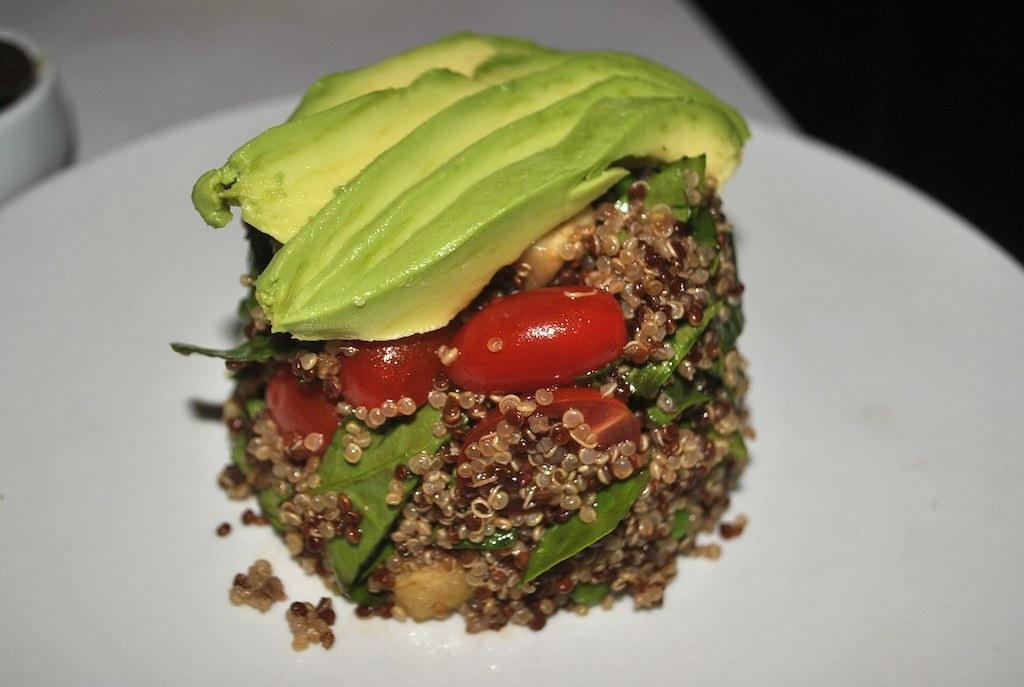What is on the plate that is visible in the image? There is food in a plate in the image. What can be seen in the background of the image? The background of the image is dark. How much debt is the food in the image responsible for? The food in the image is not responsible for any debt, as it is an inanimate object. 